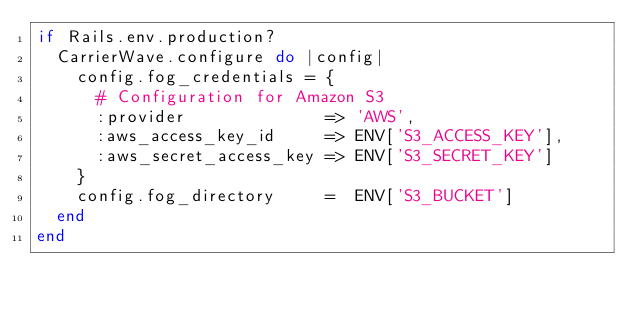Convert code to text. <code><loc_0><loc_0><loc_500><loc_500><_Ruby_>if Rails.env.production?
  CarrierWave.configure do |config|
    config.fog_credentials = {
      # Configuration for Amazon S3
      :provider              => 'AWS',
      :aws_access_key_id     => ENV['S3_ACCESS_KEY'],
      :aws_secret_access_key => ENV['S3_SECRET_KEY']
    }
    config.fog_directory     =  ENV['S3_BUCKET']
  end
end</code> 